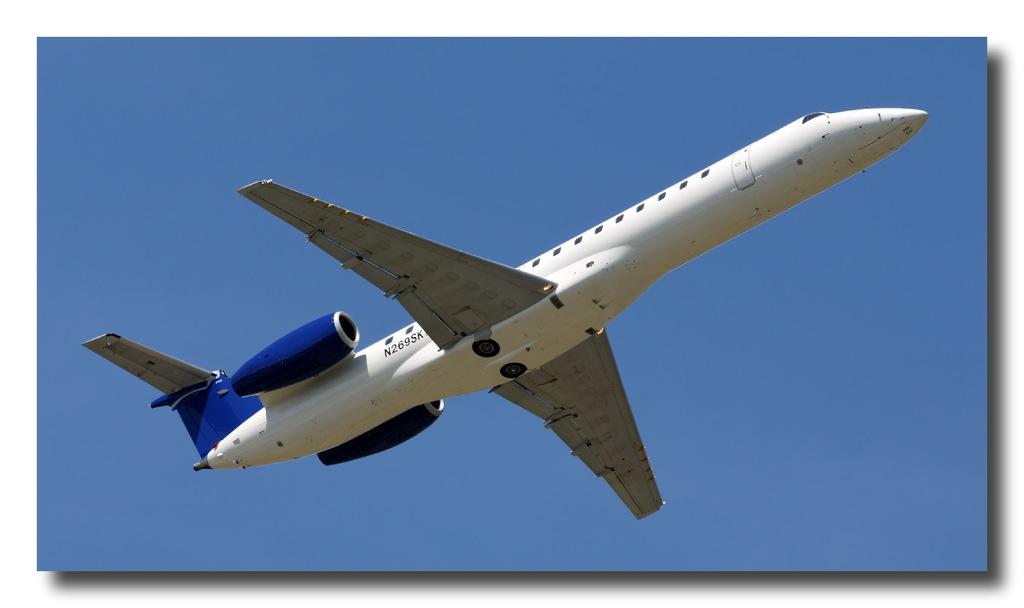What is the main subject of the image? The main subject of the image is an airplane. Where is the airplane located in the image? The airplane is in the center of the image. What can be seen in the background of the image? There is sky visible in the background of the image. What song is being sung by the airplane in the image? There is no indication in the image that the airplane is singing a song, so it cannot be determined from the picture. 